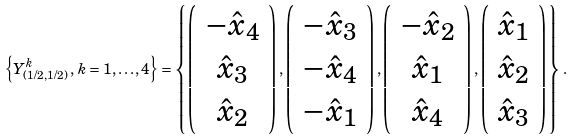Convert formula to latex. <formula><loc_0><loc_0><loc_500><loc_500>\left \{ Y _ { ( 1 / 2 , 1 / 2 ) } ^ { k } \, , \, k = 1 , \dots , 4 \right \} = \left \{ \left ( \begin{array} { c } { { - \hat { x } _ { 4 } } } \\ { { \hat { x } _ { 3 } } } \\ { { \hat { x } _ { 2 } } } \end{array} \right ) , \left ( \begin{array} { c } { { - \hat { x } _ { 3 } } } \\ { { - \hat { x } _ { 4 } } } \\ { { - \hat { x } _ { 1 } } } \end{array} \right ) , \left ( \begin{array} { c } { { - \hat { x } _ { 2 } } } \\ { { \hat { x } _ { 1 } } } \\ { { \hat { x } _ { 4 } } } \end{array} \right ) , \left ( \begin{array} { c } { { \hat { x } _ { 1 } } } \\ { { \hat { x } _ { 2 } } } \\ { { \hat { x } _ { 3 } } } \end{array} \right ) \right \} \, .</formula> 